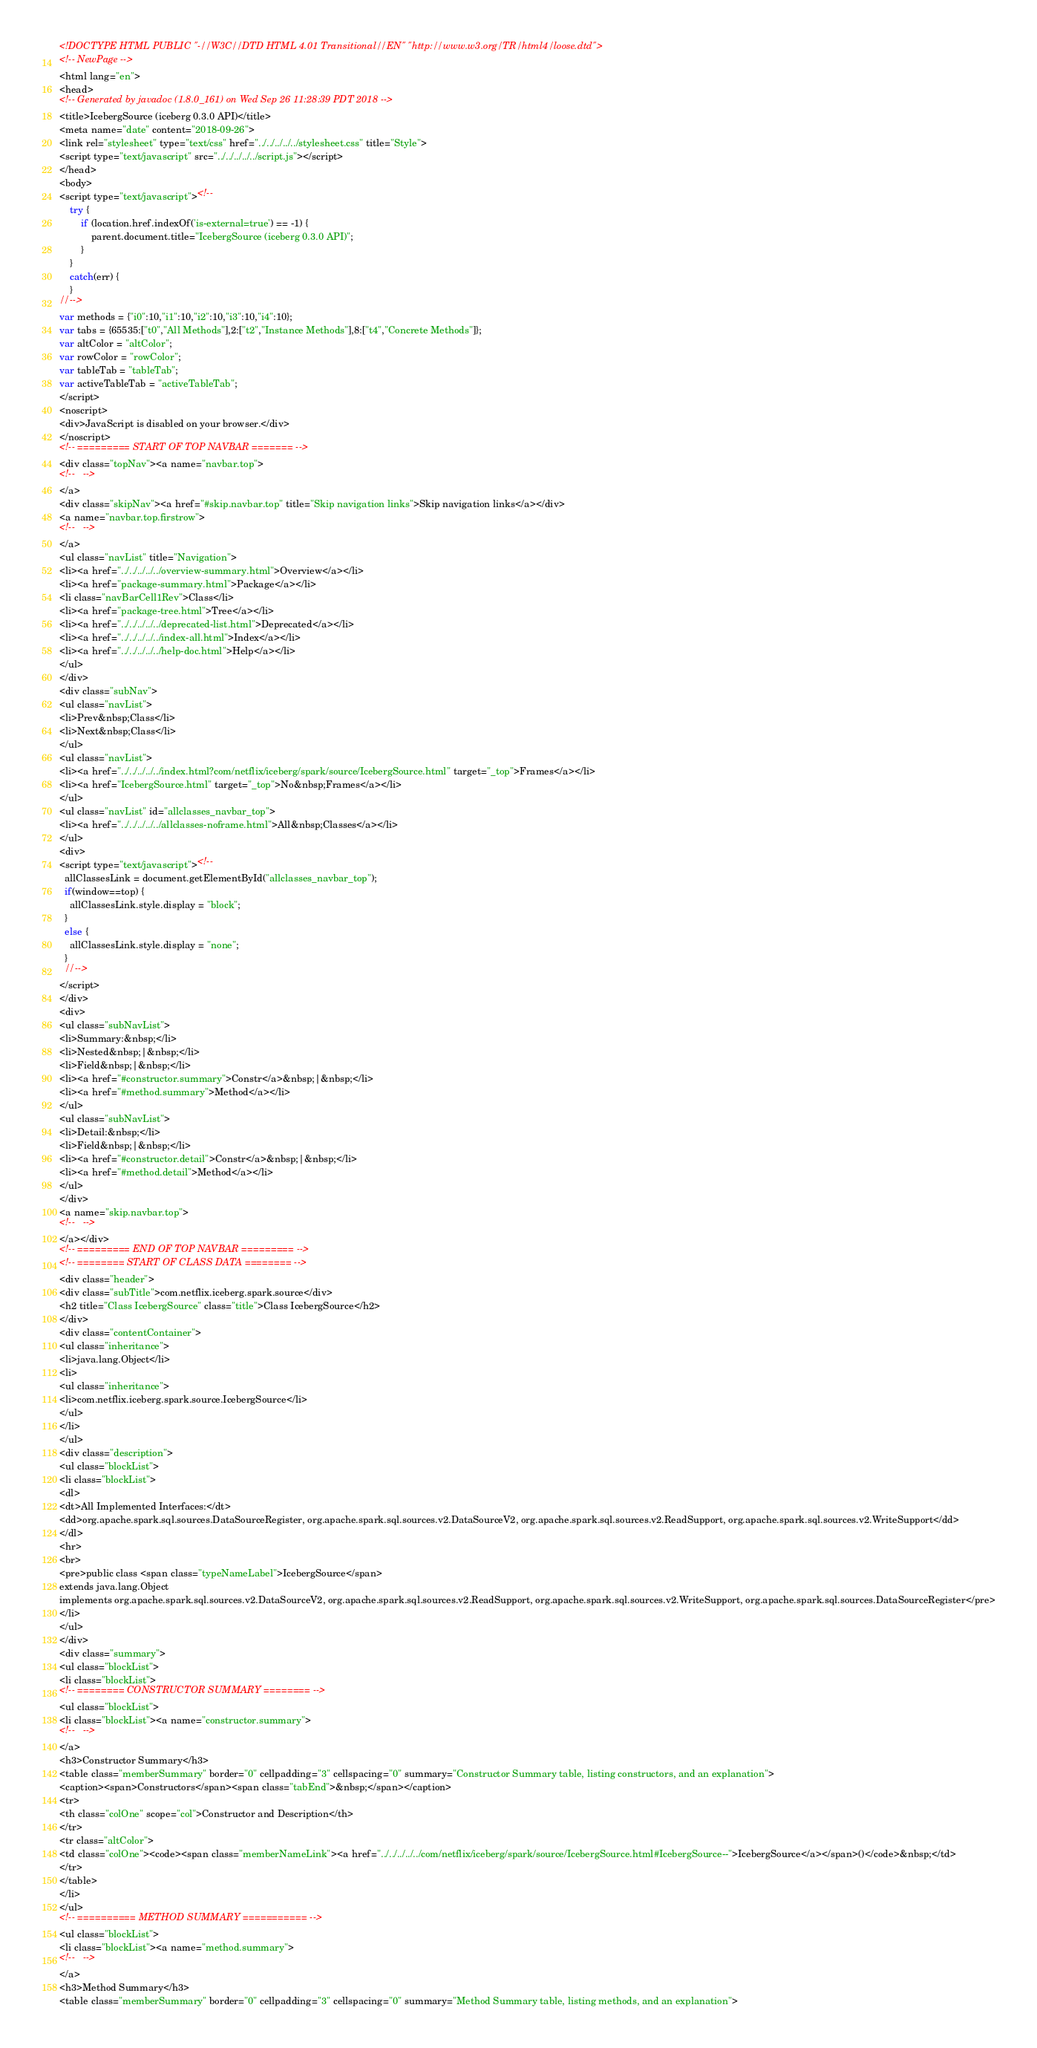<code> <loc_0><loc_0><loc_500><loc_500><_HTML_><!DOCTYPE HTML PUBLIC "-//W3C//DTD HTML 4.01 Transitional//EN" "http://www.w3.org/TR/html4/loose.dtd">
<!-- NewPage -->
<html lang="en">
<head>
<!-- Generated by javadoc (1.8.0_161) on Wed Sep 26 11:28:39 PDT 2018 -->
<title>IcebergSource (iceberg 0.3.0 API)</title>
<meta name="date" content="2018-09-26">
<link rel="stylesheet" type="text/css" href="../../../../../stylesheet.css" title="Style">
<script type="text/javascript" src="../../../../../script.js"></script>
</head>
<body>
<script type="text/javascript"><!--
    try {
        if (location.href.indexOf('is-external=true') == -1) {
            parent.document.title="IcebergSource (iceberg 0.3.0 API)";
        }
    }
    catch(err) {
    }
//-->
var methods = {"i0":10,"i1":10,"i2":10,"i3":10,"i4":10};
var tabs = {65535:["t0","All Methods"],2:["t2","Instance Methods"],8:["t4","Concrete Methods"]};
var altColor = "altColor";
var rowColor = "rowColor";
var tableTab = "tableTab";
var activeTableTab = "activeTableTab";
</script>
<noscript>
<div>JavaScript is disabled on your browser.</div>
</noscript>
<!-- ========= START OF TOP NAVBAR ======= -->
<div class="topNav"><a name="navbar.top">
<!--   -->
</a>
<div class="skipNav"><a href="#skip.navbar.top" title="Skip navigation links">Skip navigation links</a></div>
<a name="navbar.top.firstrow">
<!--   -->
</a>
<ul class="navList" title="Navigation">
<li><a href="../../../../../overview-summary.html">Overview</a></li>
<li><a href="package-summary.html">Package</a></li>
<li class="navBarCell1Rev">Class</li>
<li><a href="package-tree.html">Tree</a></li>
<li><a href="../../../../../deprecated-list.html">Deprecated</a></li>
<li><a href="../../../../../index-all.html">Index</a></li>
<li><a href="../../../../../help-doc.html">Help</a></li>
</ul>
</div>
<div class="subNav">
<ul class="navList">
<li>Prev&nbsp;Class</li>
<li>Next&nbsp;Class</li>
</ul>
<ul class="navList">
<li><a href="../../../../../index.html?com/netflix/iceberg/spark/source/IcebergSource.html" target="_top">Frames</a></li>
<li><a href="IcebergSource.html" target="_top">No&nbsp;Frames</a></li>
</ul>
<ul class="navList" id="allclasses_navbar_top">
<li><a href="../../../../../allclasses-noframe.html">All&nbsp;Classes</a></li>
</ul>
<div>
<script type="text/javascript"><!--
  allClassesLink = document.getElementById("allclasses_navbar_top");
  if(window==top) {
    allClassesLink.style.display = "block";
  }
  else {
    allClassesLink.style.display = "none";
  }
  //-->
</script>
</div>
<div>
<ul class="subNavList">
<li>Summary:&nbsp;</li>
<li>Nested&nbsp;|&nbsp;</li>
<li>Field&nbsp;|&nbsp;</li>
<li><a href="#constructor.summary">Constr</a>&nbsp;|&nbsp;</li>
<li><a href="#method.summary">Method</a></li>
</ul>
<ul class="subNavList">
<li>Detail:&nbsp;</li>
<li>Field&nbsp;|&nbsp;</li>
<li><a href="#constructor.detail">Constr</a>&nbsp;|&nbsp;</li>
<li><a href="#method.detail">Method</a></li>
</ul>
</div>
<a name="skip.navbar.top">
<!--   -->
</a></div>
<!-- ========= END OF TOP NAVBAR ========= -->
<!-- ======== START OF CLASS DATA ======== -->
<div class="header">
<div class="subTitle">com.netflix.iceberg.spark.source</div>
<h2 title="Class IcebergSource" class="title">Class IcebergSource</h2>
</div>
<div class="contentContainer">
<ul class="inheritance">
<li>java.lang.Object</li>
<li>
<ul class="inheritance">
<li>com.netflix.iceberg.spark.source.IcebergSource</li>
</ul>
</li>
</ul>
<div class="description">
<ul class="blockList">
<li class="blockList">
<dl>
<dt>All Implemented Interfaces:</dt>
<dd>org.apache.spark.sql.sources.DataSourceRegister, org.apache.spark.sql.sources.v2.DataSourceV2, org.apache.spark.sql.sources.v2.ReadSupport, org.apache.spark.sql.sources.v2.WriteSupport</dd>
</dl>
<hr>
<br>
<pre>public class <span class="typeNameLabel">IcebergSource</span>
extends java.lang.Object
implements org.apache.spark.sql.sources.v2.DataSourceV2, org.apache.spark.sql.sources.v2.ReadSupport, org.apache.spark.sql.sources.v2.WriteSupport, org.apache.spark.sql.sources.DataSourceRegister</pre>
</li>
</ul>
</div>
<div class="summary">
<ul class="blockList">
<li class="blockList">
<!-- ======== CONSTRUCTOR SUMMARY ======== -->
<ul class="blockList">
<li class="blockList"><a name="constructor.summary">
<!--   -->
</a>
<h3>Constructor Summary</h3>
<table class="memberSummary" border="0" cellpadding="3" cellspacing="0" summary="Constructor Summary table, listing constructors, and an explanation">
<caption><span>Constructors</span><span class="tabEnd">&nbsp;</span></caption>
<tr>
<th class="colOne" scope="col">Constructor and Description</th>
</tr>
<tr class="altColor">
<td class="colOne"><code><span class="memberNameLink"><a href="../../../../../com/netflix/iceberg/spark/source/IcebergSource.html#IcebergSource--">IcebergSource</a></span>()</code>&nbsp;</td>
</tr>
</table>
</li>
</ul>
<!-- ========== METHOD SUMMARY =========== -->
<ul class="blockList">
<li class="blockList"><a name="method.summary">
<!--   -->
</a>
<h3>Method Summary</h3>
<table class="memberSummary" border="0" cellpadding="3" cellspacing="0" summary="Method Summary table, listing methods, and an explanation"></code> 